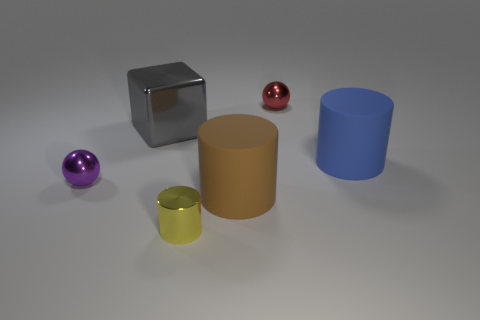The large object that is both behind the purple metal ball and on the left side of the red ball has what shape?
Ensure brevity in your answer.  Cube. Is the material of the large brown object the same as the tiny yellow cylinder?
Offer a terse response. No. There is a shiny cylinder that is the same size as the purple metallic object; what is its color?
Your response must be concise. Yellow. What color is the tiny thing that is behind the big brown rubber object and on the left side of the red thing?
Your response must be concise. Purple. There is a matte object that is to the right of the metallic ball right of the small metal ball that is on the left side of the tiny yellow shiny cylinder; how big is it?
Your response must be concise. Large. What is the material of the tiny yellow cylinder?
Offer a very short reply. Metal. Are the small cylinder and the large cylinder behind the purple object made of the same material?
Provide a short and direct response. No. Is there anything else of the same color as the block?
Give a very brief answer. No. Is there a metal sphere in front of the small metallic ball behind the large blue thing that is to the right of the big shiny block?
Provide a succinct answer. Yes. What color is the metallic cube?
Offer a very short reply. Gray. 